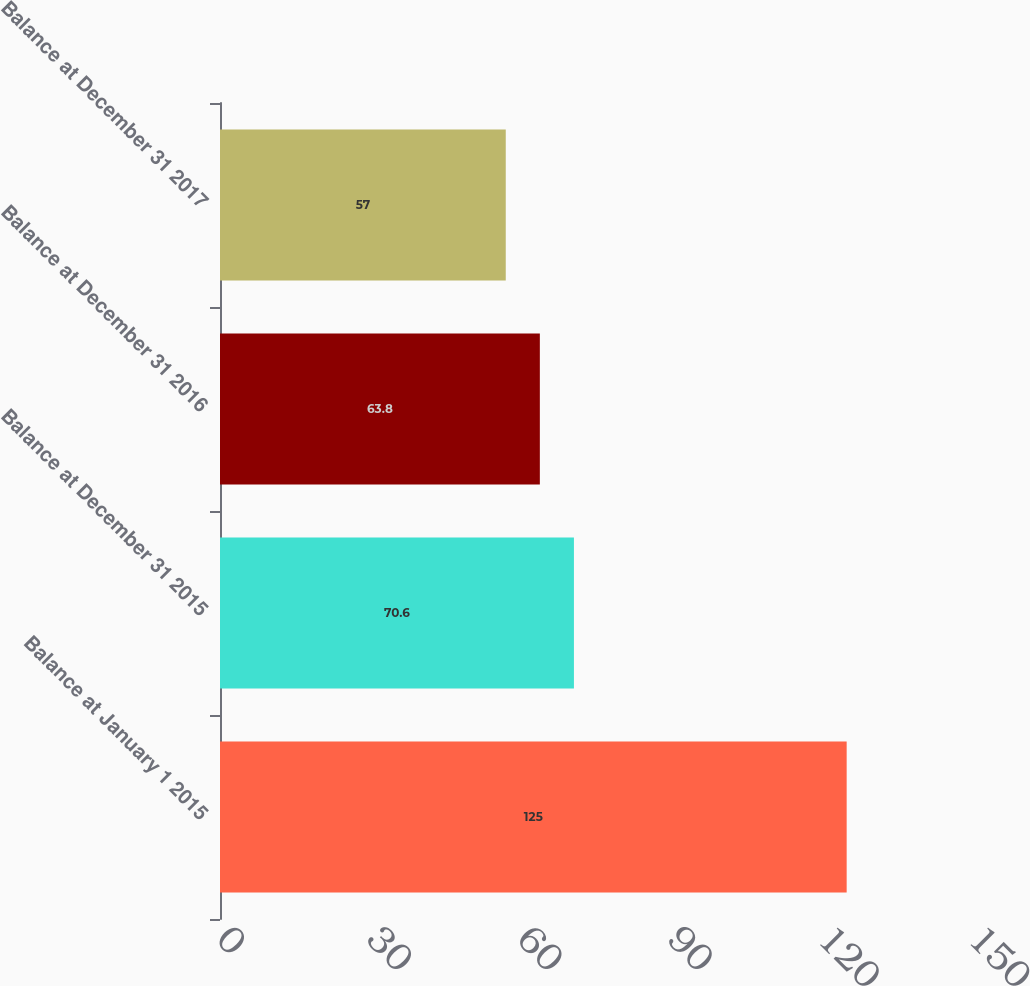Convert chart to OTSL. <chart><loc_0><loc_0><loc_500><loc_500><bar_chart><fcel>Balance at January 1 2015<fcel>Balance at December 31 2015<fcel>Balance at December 31 2016<fcel>Balance at December 31 2017<nl><fcel>125<fcel>70.6<fcel>63.8<fcel>57<nl></chart> 